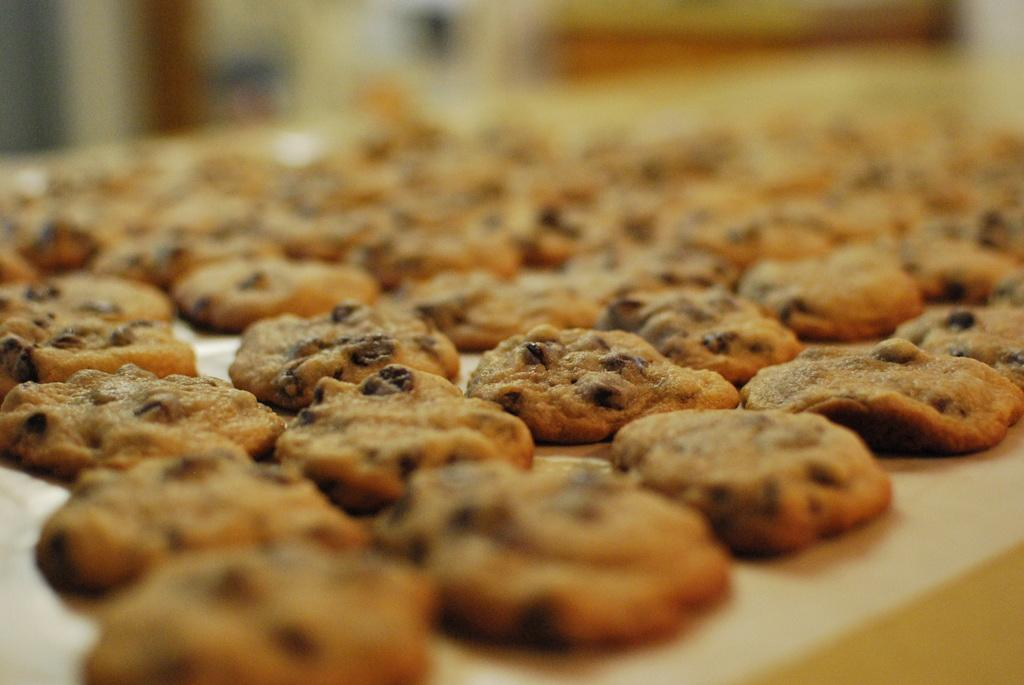What type of food can be seen in the image? There are cookies in the image. How are the cookies arranged in the image? The cookies are placed on a tray. What type of root can be seen growing near the cookies in the image? There is no root visible in the image; it only shows cookies placed on a tray. 